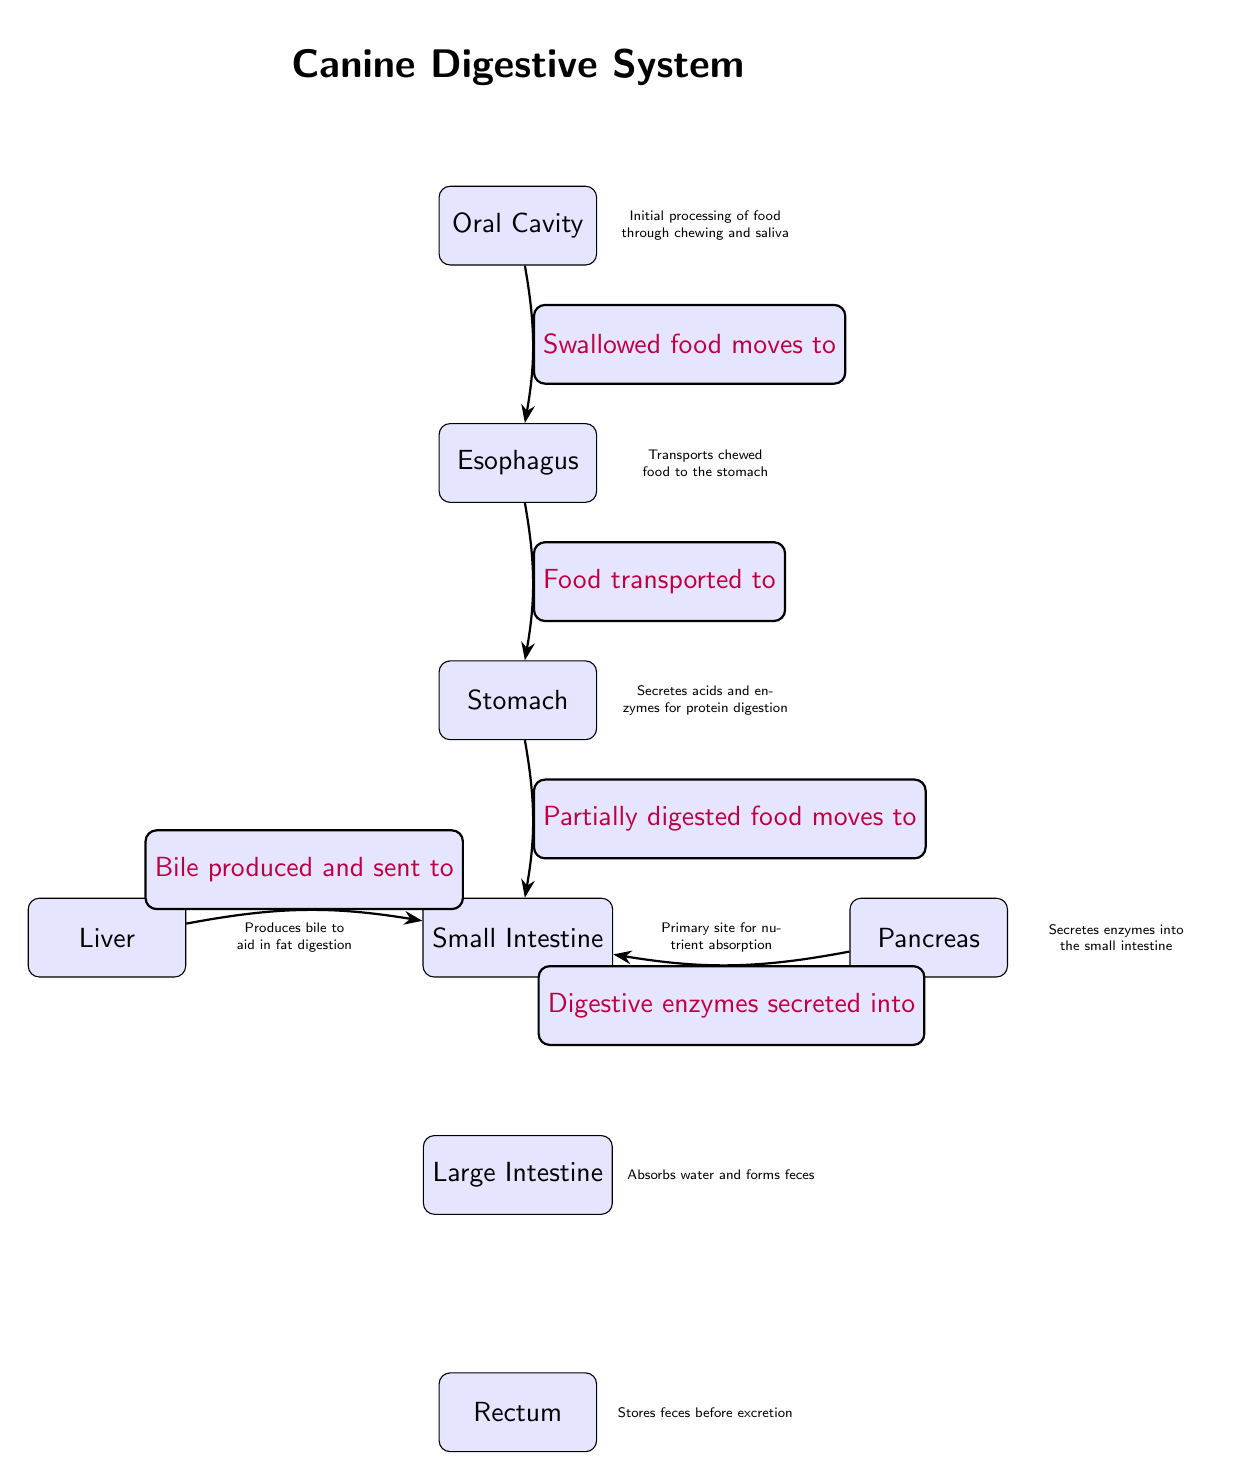What is the first node in the diagram? The first node represents the starting point of the digestive system, which is labeled as the Oral Cavity.
Answer: Oral Cavity How many nodes are present in the diagram? By counting all the distinct parts of the digestive system represented, the diagram has a total of 8 nodes.
Answer: 8 What does the esophagus do? The function of the esophagus, according to the diagram, is to transport chewed food to the stomach.
Answer: Transports chewed food to the stomach From which organ is bile produced? The diagram specifies that the liver is the organ responsible for producing bile.
Answer: Liver What moves from the small intestine to the large intestine? The diagram states that waste moves from the small intestine to the large intestine after nutrient absorption completes.
Answer: Waste Which organ secretes enzymes into the small intestine? The pancreas is indicated in the diagram as the organ that secretes enzymes into the small intestine.
Answer: Pancreas What is the last node in the digestive system flow? According to the flow in the diagram, the last node represents the rectum, where waste is stored before excretion.
Answer: Rectum What happens to water in the large intestine? The diagram indicates that water is absorbed in the large intestine, contributing to feces formation.
Answer: Water absorbed Describe the relationship between the liver and the small intestine. The diagram shows that the liver produces bile which is sent to the small intestine, indicating a one-way flow of bile to aid digestion.
Answer: Bile produced and sent to small intestine 